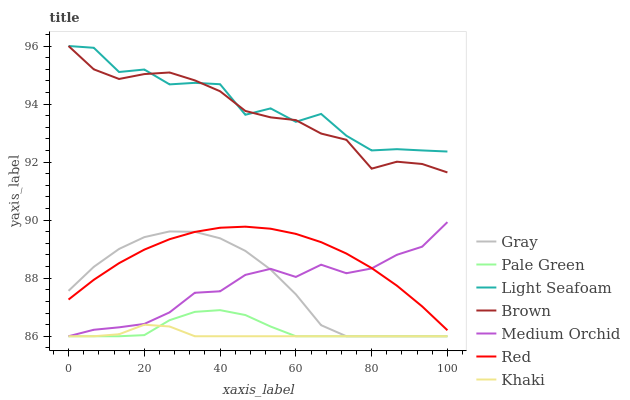Does Khaki have the minimum area under the curve?
Answer yes or no. Yes. Does Light Seafoam have the maximum area under the curve?
Answer yes or no. Yes. Does Brown have the minimum area under the curve?
Answer yes or no. No. Does Brown have the maximum area under the curve?
Answer yes or no. No. Is Khaki the smoothest?
Answer yes or no. Yes. Is Light Seafoam the roughest?
Answer yes or no. Yes. Is Brown the smoothest?
Answer yes or no. No. Is Brown the roughest?
Answer yes or no. No. Does Brown have the lowest value?
Answer yes or no. No. Does Light Seafoam have the highest value?
Answer yes or no. Yes. Does Khaki have the highest value?
Answer yes or no. No. Is Red less than Light Seafoam?
Answer yes or no. Yes. Is Light Seafoam greater than Medium Orchid?
Answer yes or no. Yes. Does Khaki intersect Pale Green?
Answer yes or no. Yes. Is Khaki less than Pale Green?
Answer yes or no. No. Is Khaki greater than Pale Green?
Answer yes or no. No. Does Red intersect Light Seafoam?
Answer yes or no. No. 